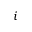<formula> <loc_0><loc_0><loc_500><loc_500>i</formula> 